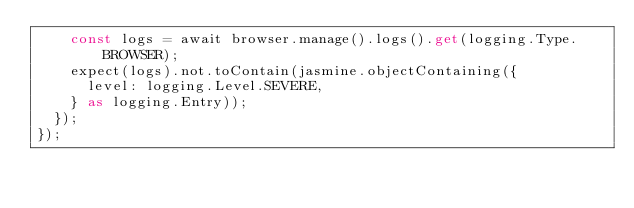<code> <loc_0><loc_0><loc_500><loc_500><_TypeScript_>    const logs = await browser.manage().logs().get(logging.Type.BROWSER);
    expect(logs).not.toContain(jasmine.objectContaining({
      level: logging.Level.SEVERE,
    } as logging.Entry));
  });
});
</code> 